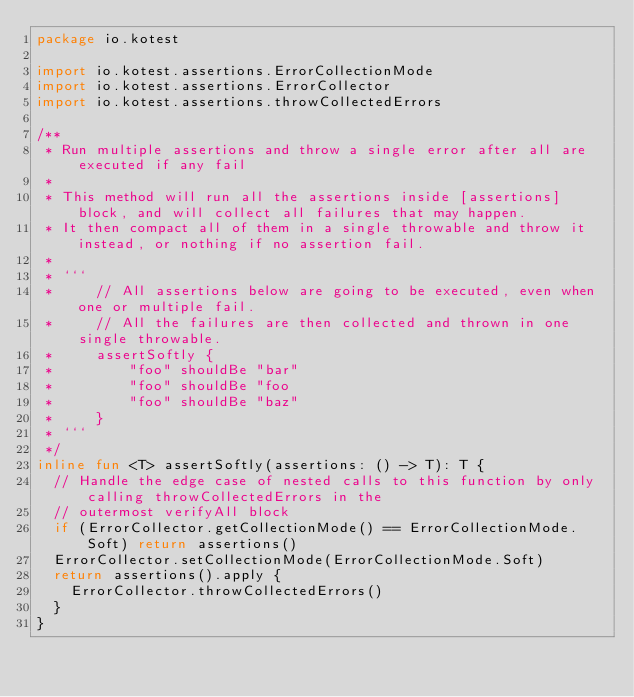<code> <loc_0><loc_0><loc_500><loc_500><_Kotlin_>package io.kotest

import io.kotest.assertions.ErrorCollectionMode
import io.kotest.assertions.ErrorCollector
import io.kotest.assertions.throwCollectedErrors

/**
 * Run multiple assertions and throw a single error after all are executed if any fail
 *
 * This method will run all the assertions inside [assertions] block, and will collect all failures that may happen.
 * It then compact all of them in a single throwable and throw it instead, or nothing if no assertion fail.
 *
 * ```
 *     // All assertions below are going to be executed, even when one or multiple fail.
 *     // All the failures are then collected and thrown in one single throwable.
 *     assertSoftly {
 *         "foo" shouldBe "bar"
 *         "foo" shouldBe "foo
 *         "foo" shouldBe "baz"
 *     }
 * ```
 */
inline fun <T> assertSoftly(assertions: () -> T): T {
  // Handle the edge case of nested calls to this function by only calling throwCollectedErrors in the
  // outermost verifyAll block
  if (ErrorCollector.getCollectionMode() == ErrorCollectionMode.Soft) return assertions()
  ErrorCollector.setCollectionMode(ErrorCollectionMode.Soft)
  return assertions().apply {
    ErrorCollector.throwCollectedErrors()
  }
}
</code> 